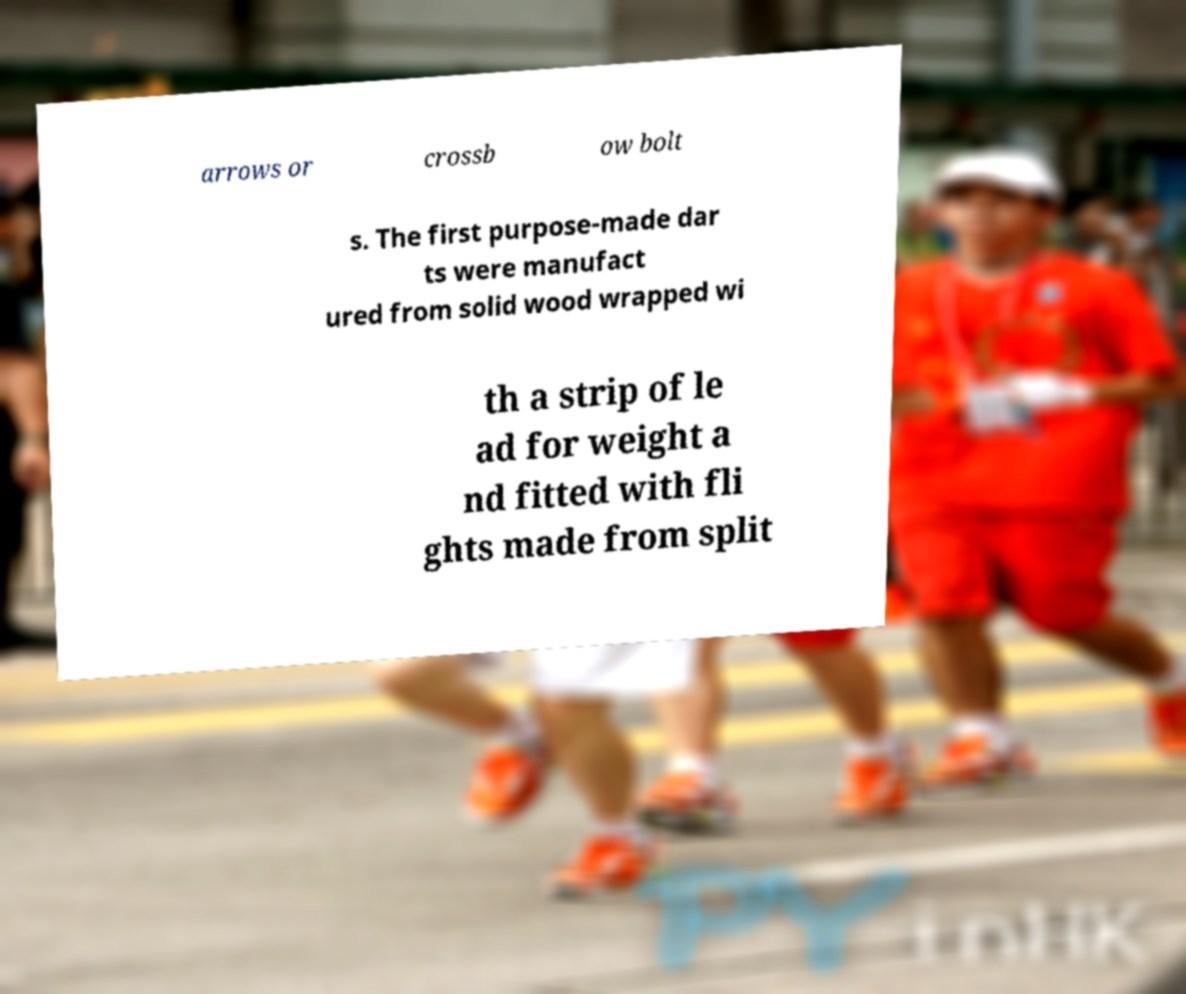For documentation purposes, I need the text within this image transcribed. Could you provide that? arrows or crossb ow bolt s. The first purpose-made dar ts were manufact ured from solid wood wrapped wi th a strip of le ad for weight a nd fitted with fli ghts made from split 